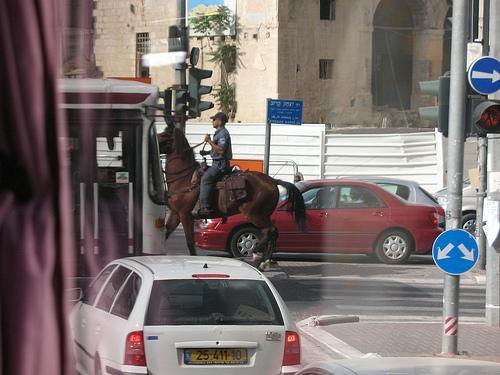Briefly describe the scene presented in the image as if you were narrating a story. Our protagonist, an officer on a brown horse, navigates his way through the busy city streets, as vehicles like a red car and a white bus pass by. Amidst the hustle and bustle, a round blue traffic sign stands out, providing guidance to the drivers. Pretend you are giving directions to a friend using this image. Describe the location of the round blue sign and its appearance. As you move down the street, you'll spot a mounted police officer on a brown horse near a red car. Look further ahead, and you'll find a round blue sign with white arrows attached to a pole on the right side of the road. That's your landmark. How many types of vehicles are there in the image, and name them. There are three types of vehicles in the image: a red car, a white station wagon, and a white bus. Explain the visual relationships between different objects in the image. The police officer on a brown horse is positioned in the middle of the road, with a red car immediately behind them. The white station wagon is further back in the street, and a round blue traffic sign with white arrows is visible in the distance. An electric traffic control signal also oversees the flow of traffic. In a poetic manner, describe the overall vibe of the image. Amid the urban jungle's orchestration of chaos, a majestic figure stands out; an officer atop his trusty steed, a brown horse navigating the cacophony of colors and sounds. Vehicles of red and white find their way through the cityscape, while a blue beacon of direction graces the scene with its calming presence. List five objects in the image that directly interact with the traffic situation. 5. Electric traffic control signal Imagine you are a tour guide describing this image to a group of tourists. Mention the primary focus and some notable details. Ladies and gentlemen, this image captures a mounted police officer on a brown horse in the middle of traffic, alongside a red car and a white station wagon. You can also see a round blue sign with white arrows and a yellow license plate on one of the cars in the scene. In a matter-of-fact tone, identify the different objects present in the image. The image contains a mounted police officer on a brown horse, a red car, a white station wagon, a yellow license plate, a round blue sign with white arrows, a red tail light, an electric traffic control signal, a brick paved sidewalk, and a front of a bus. What is the most unusual object in the image, and why? The most unusual object in the image is the mounted police officer on a brown horse, as it is not common to see a horse amidst modern traffic, where cars and buses dominate the roads. As a curious observer, ask three questions about the image. What is the purpose of the round blue sign with white arrows? Is the mounted police officer performing any specific duty? How does the electric traffic control signal influence the flow of traffic? 